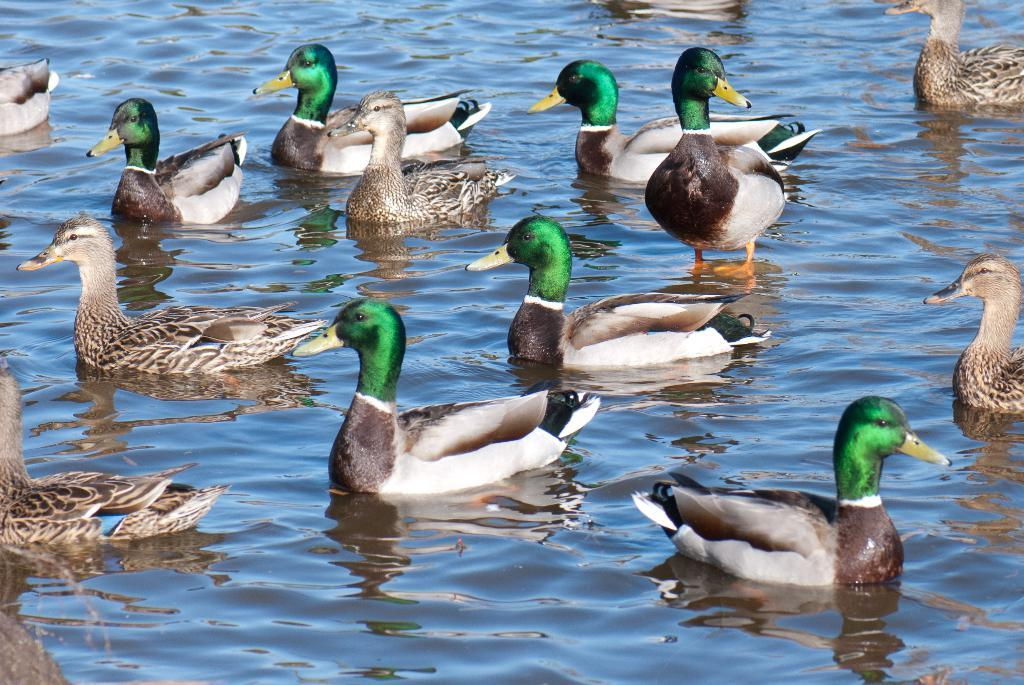What type of animals can be seen in the image? There are many ducks in the image. What is the ducks' location in relation to the water? The ducks are floating on the water surface. What type of teeth does the grandfather have in the image? There is no grandfather or teeth present in the image; it features many ducks floating on the water surface. What type of rice is being cooked in the image? There is no rice or cooking activity present in the image. 